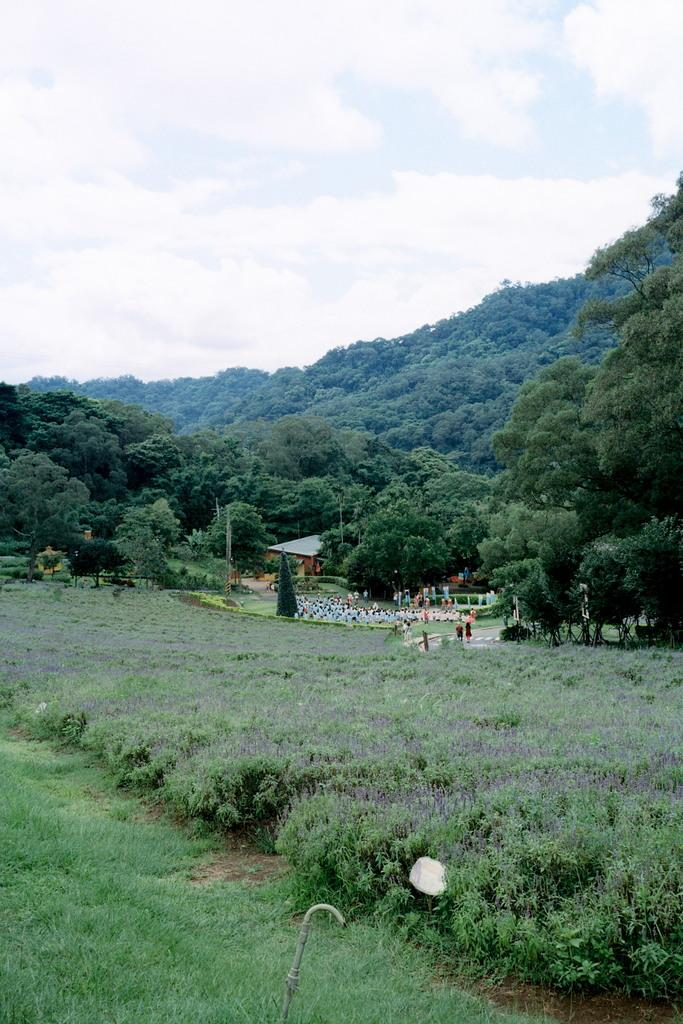What is the main feature of the image? There are many trees in the image. What are the people in the image doing? The people are sitting on the ground in front of the trees. What can be seen in the background of the image? The back of the image includes clouds. What is visible above the trees in the image? The sky is visible in the image. What type of pain can be seen on the faces of the people in the image? There is no indication of pain on the faces of the people in the image; they are simply sitting on the ground. What is the stem of the tree used for in the image? There is no stem of a tree visible in the image, as it focuses on the trees' trunks and leaves. 